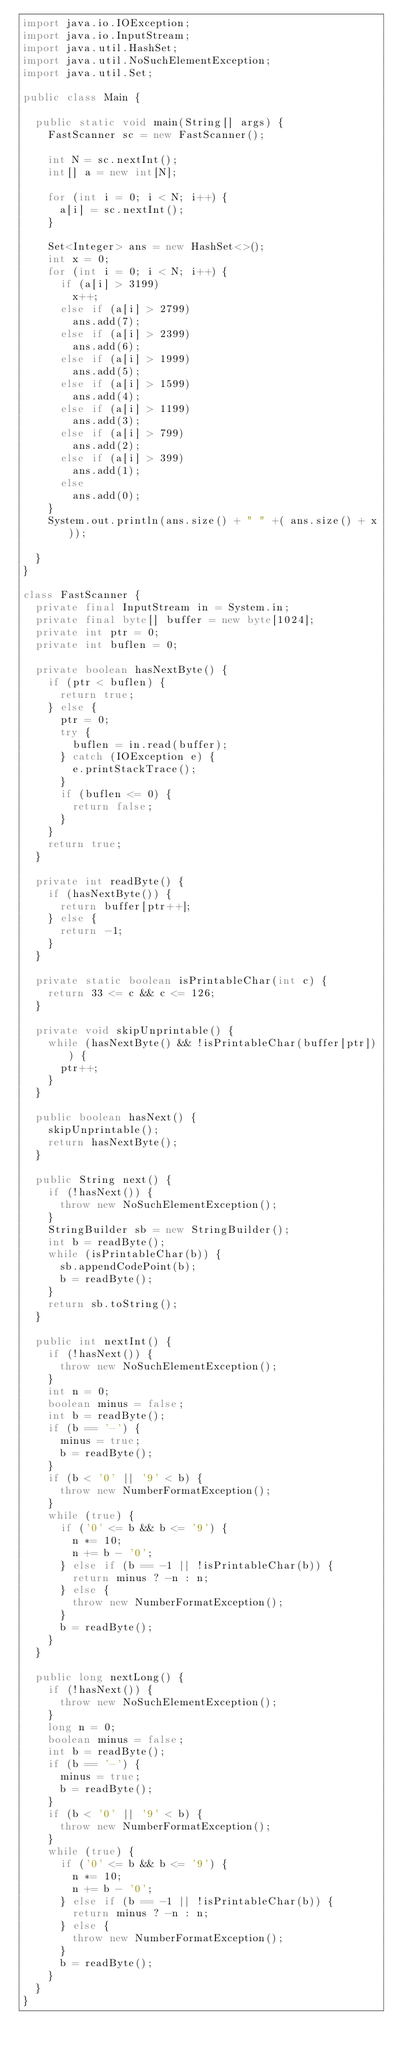Convert code to text. <code><loc_0><loc_0><loc_500><loc_500><_Java_>import java.io.IOException;
import java.io.InputStream;
import java.util.HashSet;
import java.util.NoSuchElementException;
import java.util.Set;

public class Main {

  public static void main(String[] args) {
    FastScanner sc = new FastScanner();

    int N = sc.nextInt();
    int[] a = new int[N];

    for (int i = 0; i < N; i++) {
      a[i] = sc.nextInt();
    }

    Set<Integer> ans = new HashSet<>();
    int x = 0;
    for (int i = 0; i < N; i++) {
      if (a[i] > 3199)
        x++;
      else if (a[i] > 2799)
        ans.add(7);
      else if (a[i] > 2399)
        ans.add(6);
      else if (a[i] > 1999)
        ans.add(5);
      else if (a[i] > 1599)
        ans.add(4);
      else if (a[i] > 1199)
        ans.add(3);
      else if (a[i] > 799)
        ans.add(2);
      else if (a[i] > 399)
        ans.add(1);
      else
        ans.add(0);
    }
    System.out.println(ans.size() + " " +( ans.size() + x));

  }
}

class FastScanner {
  private final InputStream in = System.in;
  private final byte[] buffer = new byte[1024];
  private int ptr = 0;
  private int buflen = 0;

  private boolean hasNextByte() {
    if (ptr < buflen) {
      return true;
    } else {
      ptr = 0;
      try {
        buflen = in.read(buffer);
      } catch (IOException e) {
        e.printStackTrace();
      }
      if (buflen <= 0) {
        return false;
      }
    }
    return true;
  }

  private int readByte() {
    if (hasNextByte()) {
      return buffer[ptr++];
    } else {
      return -1;
    }
  }

  private static boolean isPrintableChar(int c) {
    return 33 <= c && c <= 126;
  }

  private void skipUnprintable() {
    while (hasNextByte() && !isPrintableChar(buffer[ptr])) {
      ptr++;
    }
  }

  public boolean hasNext() {
    skipUnprintable();
    return hasNextByte();
  }

  public String next() {
    if (!hasNext()) {
      throw new NoSuchElementException();
    }
    StringBuilder sb = new StringBuilder();
    int b = readByte();
    while (isPrintableChar(b)) {
      sb.appendCodePoint(b);
      b = readByte();
    }
    return sb.toString();
  }

  public int nextInt() {
    if (!hasNext()) {
      throw new NoSuchElementException();
    }
    int n = 0;
    boolean minus = false;
    int b = readByte();
    if (b == '-') {
      minus = true;
      b = readByte();
    }
    if (b < '0' || '9' < b) {
      throw new NumberFormatException();
    }
    while (true) {
      if ('0' <= b && b <= '9') {
        n *= 10;
        n += b - '0';
      } else if (b == -1 || !isPrintableChar(b)) {
        return minus ? -n : n;
      } else {
        throw new NumberFormatException();
      }
      b = readByte();
    }
  }

  public long nextLong() {
    if (!hasNext()) {
      throw new NoSuchElementException();
    }
    long n = 0;
    boolean minus = false;
    int b = readByte();
    if (b == '-') {
      minus = true;
      b = readByte();
    }
    if (b < '0' || '9' < b) {
      throw new NumberFormatException();
    }
    while (true) {
      if ('0' <= b && b <= '9') {
        n *= 10;
        n += b - '0';
      } else if (b == -1 || !isPrintableChar(b)) {
        return minus ? -n : n;
      } else {
        throw new NumberFormatException();
      }
      b = readByte();
    }
  }
}</code> 